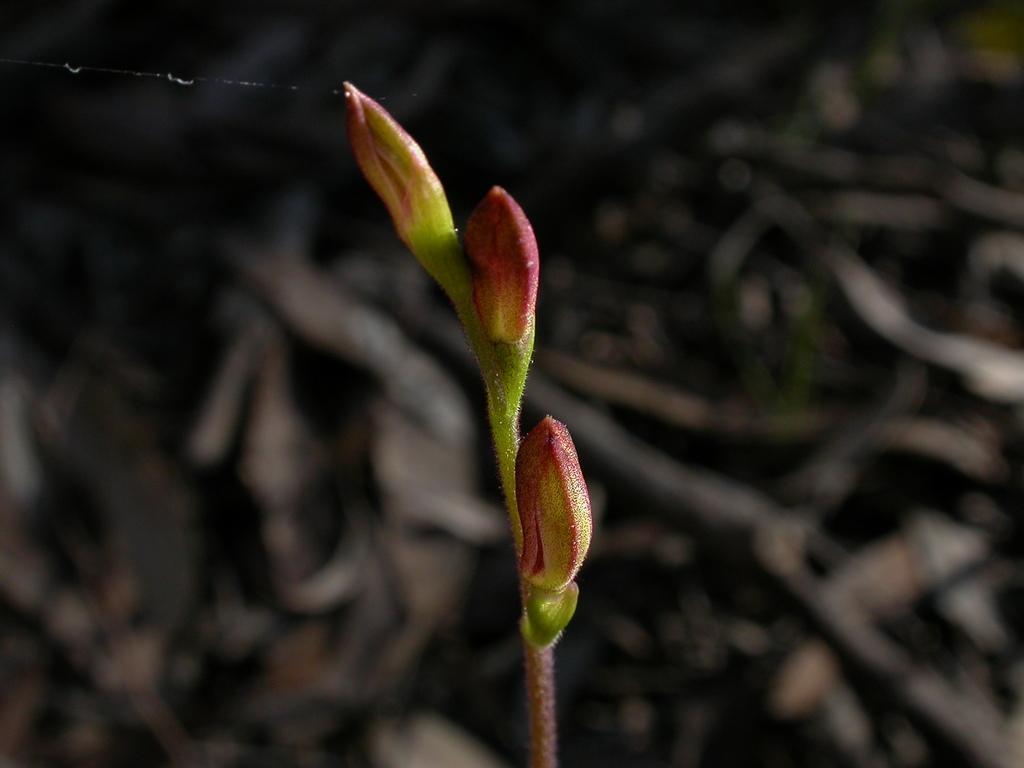Could you give a brief overview of what you see in this image? In the picture we can see a plant with three flower buds which are pink in color with some green color shade on it and in the background we can see dried twigs. 